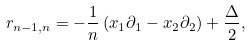Convert formula to latex. <formula><loc_0><loc_0><loc_500><loc_500>r _ { n - 1 , n } = - \frac { 1 } { n } \left ( x _ { 1 } \partial _ { 1 } - x _ { 2 } \partial _ { 2 } \right ) + \frac { \Delta } { 2 } ,</formula> 